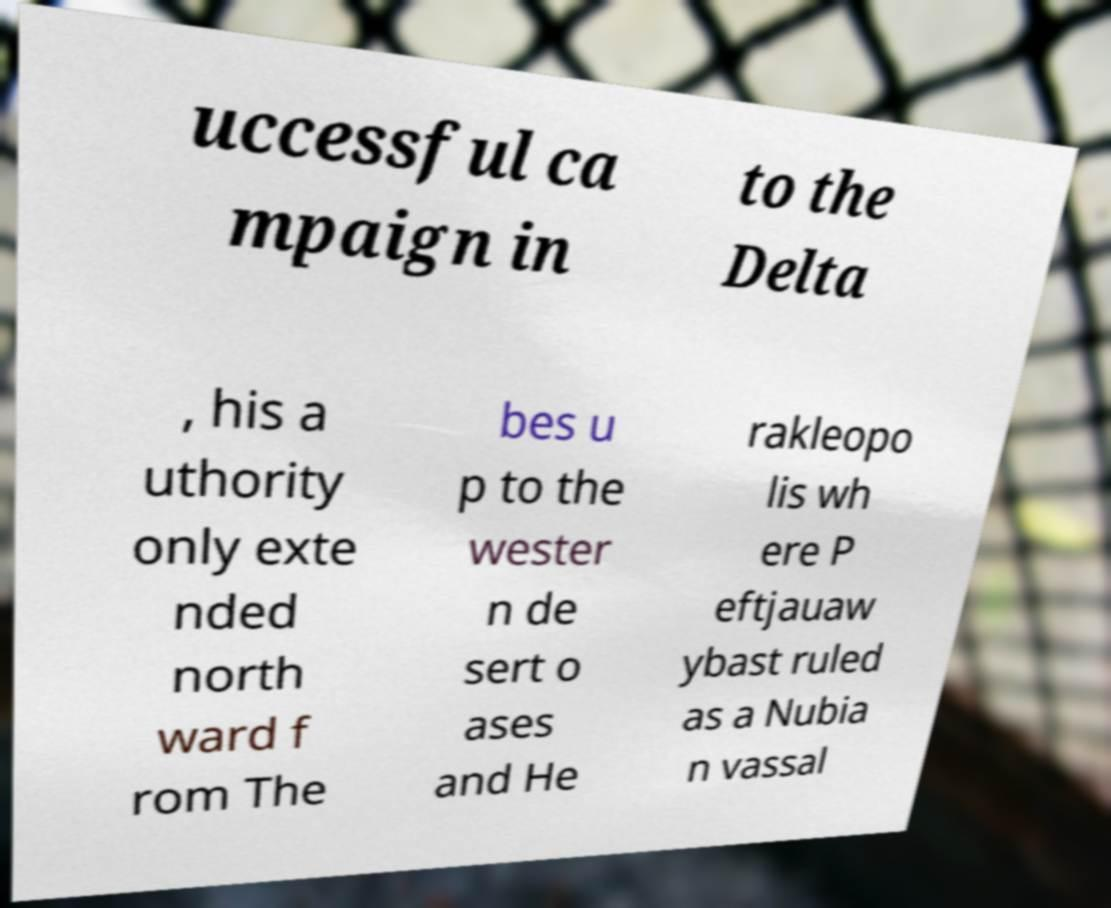I need the written content from this picture converted into text. Can you do that? uccessful ca mpaign in to the Delta , his a uthority only exte nded north ward f rom The bes u p to the wester n de sert o ases and He rakleopo lis wh ere P eftjauaw ybast ruled as a Nubia n vassal 